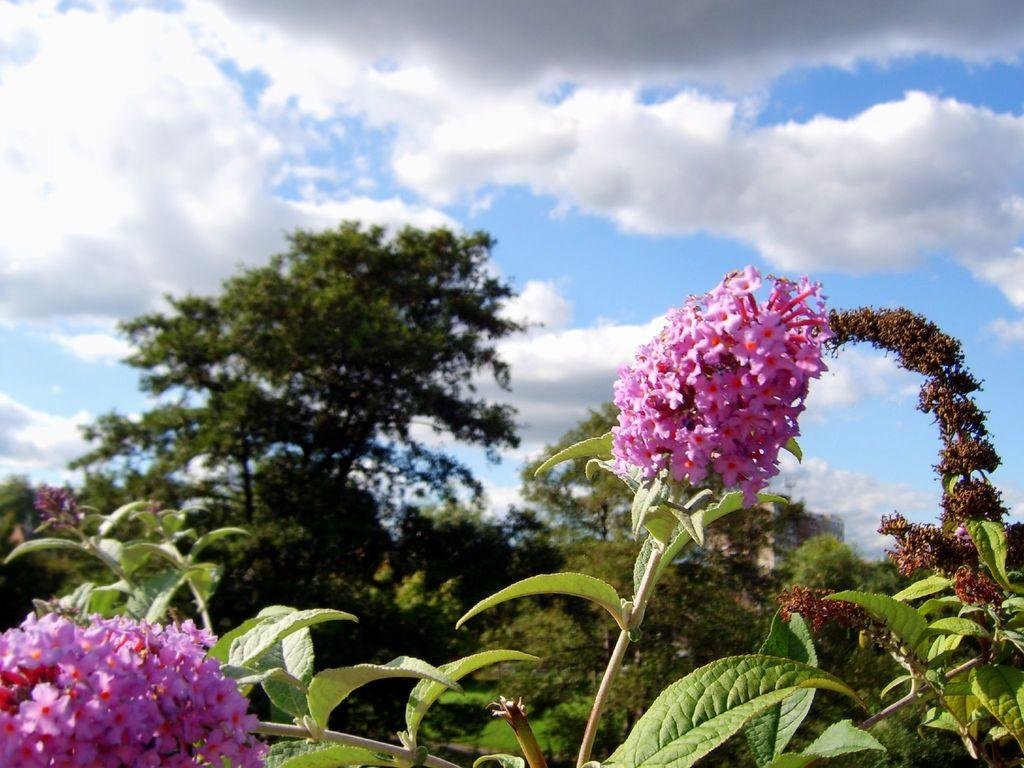What is visible in the background of the image? The sky is visible in the image. What can be seen in the sky? There are clouds in the sky. What type of vegetation is present in the image? There are trees, plants, and flowers in the image. What type of grain is being harvested in the image? There is no grain present in the image; it features the sky, clouds, trees, plants, and flowers. 